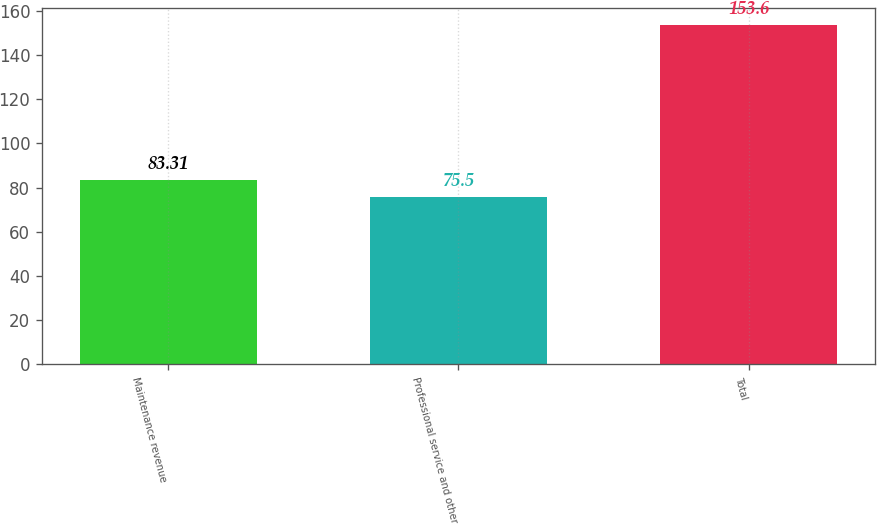<chart> <loc_0><loc_0><loc_500><loc_500><bar_chart><fcel>Maintenance revenue<fcel>Professional service and other<fcel>Total<nl><fcel>83.31<fcel>75.5<fcel>153.6<nl></chart> 